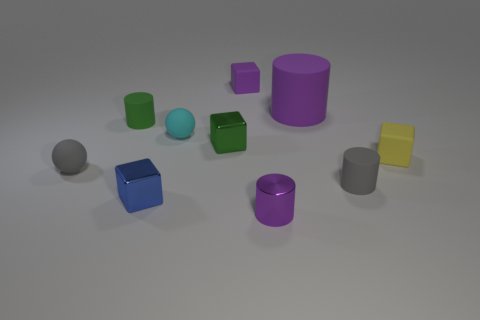Subtract all rubber cylinders. How many cylinders are left? 1 Subtract all gray blocks. How many purple cylinders are left? 2 Subtract all gray cylinders. How many cylinders are left? 3 Subtract all red cylinders. Subtract all gray balls. How many cylinders are left? 4 Add 1 cyan spheres. How many cyan spheres are left? 2 Add 6 small green matte cylinders. How many small green matte cylinders exist? 7 Subtract 0 brown blocks. How many objects are left? 10 Subtract all balls. How many objects are left? 8 Subtract all tiny yellow cubes. Subtract all small gray balls. How many objects are left? 8 